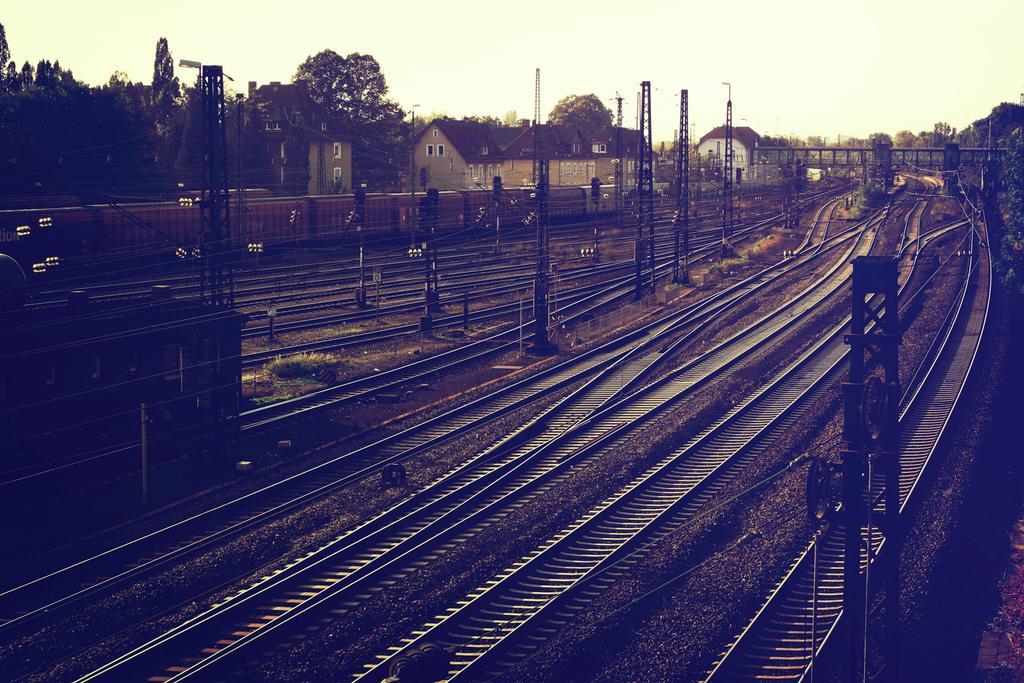In one or two sentences, can you explain what this image depicts? In this image, there are some railway tracks, there are some poles, at the background there are some homes and there are some trees, at the top there is a sky. 